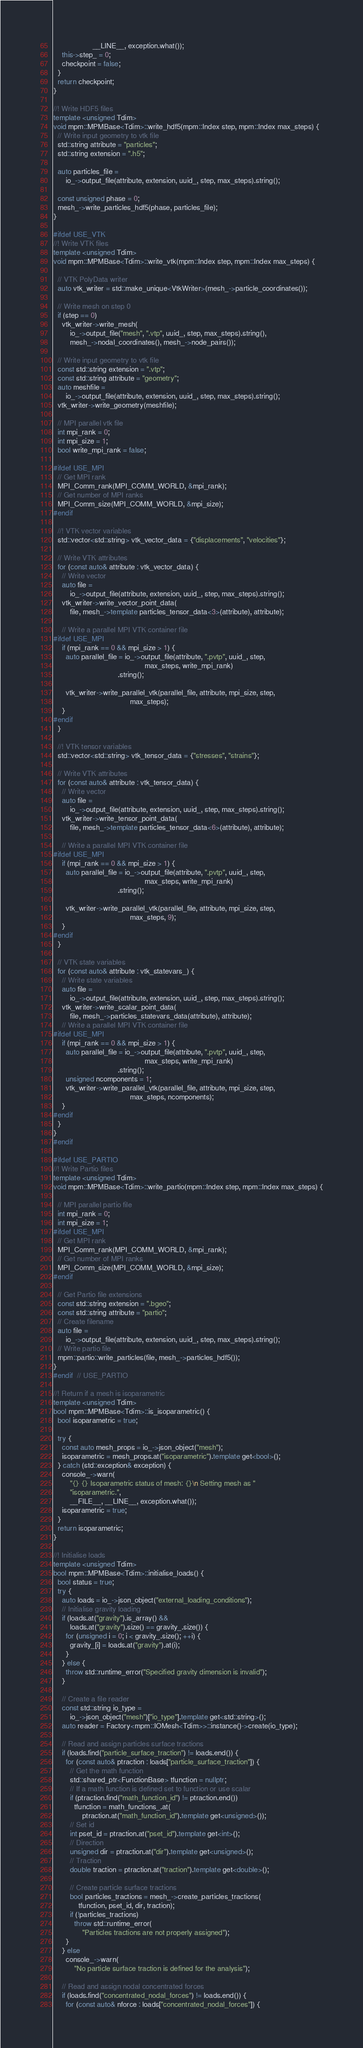Convert code to text. <code><loc_0><loc_0><loc_500><loc_500><_C++_>                   __LINE__, exception.what());
    this->step_ = 0;
    checkpoint = false;
  }
  return checkpoint;
}

//! Write HDF5 files
template <unsigned Tdim>
void mpm::MPMBase<Tdim>::write_hdf5(mpm::Index step, mpm::Index max_steps) {
  // Write input geometry to vtk file
  std::string attribute = "particles";
  std::string extension = ".h5";

  auto particles_file =
      io_->output_file(attribute, extension, uuid_, step, max_steps).string();

  const unsigned phase = 0;
  mesh_->write_particles_hdf5(phase, particles_file);
}

#ifdef USE_VTK
//! Write VTK files
template <unsigned Tdim>
void mpm::MPMBase<Tdim>::write_vtk(mpm::Index step, mpm::Index max_steps) {

  // VTK PolyData writer
  auto vtk_writer = std::make_unique<VtkWriter>(mesh_->particle_coordinates());

  // Write mesh on step 0
  if (step == 0)
    vtk_writer->write_mesh(
        io_->output_file("mesh", ".vtp", uuid_, step, max_steps).string(),
        mesh_->nodal_coordinates(), mesh_->node_pairs());

  // Write input geometry to vtk file
  const std::string extension = ".vtp";
  const std::string attribute = "geometry";
  auto meshfile =
      io_->output_file(attribute, extension, uuid_, step, max_steps).string();
  vtk_writer->write_geometry(meshfile);

  // MPI parallel vtk file
  int mpi_rank = 0;
  int mpi_size = 1;
  bool write_mpi_rank = false;

#ifdef USE_MPI
  // Get MPI rank
  MPI_Comm_rank(MPI_COMM_WORLD, &mpi_rank);
  // Get number of MPI ranks
  MPI_Comm_size(MPI_COMM_WORLD, &mpi_size);
#endif

  //! VTK vector variables
  std::vector<std::string> vtk_vector_data = {"displacements", "velocities"};

  // Write VTK attributes
  for (const auto& attribute : vtk_vector_data) {
    // Write vector
    auto file =
        io_->output_file(attribute, extension, uuid_, step, max_steps).string();
    vtk_writer->write_vector_point_data(
        file, mesh_->template particles_tensor_data<3>(attribute), attribute);

    // Write a parallel MPI VTK container file
#ifdef USE_MPI
    if (mpi_rank == 0 && mpi_size > 1) {
      auto parallel_file = io_->output_file(attribute, ".pvtp", uuid_, step,
                                            max_steps, write_mpi_rank)
                               .string();

      vtk_writer->write_parallel_vtk(parallel_file, attribute, mpi_size, step,
                                     max_steps);
    }
#endif
  }

  //! VTK tensor variables
  std::vector<std::string> vtk_tensor_data = {"stresses", "strains"};

  // Write VTK attributes
  for (const auto& attribute : vtk_tensor_data) {
    // Write vector
    auto file =
        io_->output_file(attribute, extension, uuid_, step, max_steps).string();
    vtk_writer->write_tensor_point_data(
        file, mesh_->template particles_tensor_data<6>(attribute), attribute);

    // Write a parallel MPI VTK container file
#ifdef USE_MPI
    if (mpi_rank == 0 && mpi_size > 1) {
      auto parallel_file = io_->output_file(attribute, ".pvtp", uuid_, step,
                                            max_steps, write_mpi_rank)
                               .string();

      vtk_writer->write_parallel_vtk(parallel_file, attribute, mpi_size, step,
                                     max_steps, 9);
    }
#endif
  }

  // VTK state variables
  for (const auto& attribute : vtk_statevars_) {
    // Write state variables
    auto file =
        io_->output_file(attribute, extension, uuid_, step, max_steps).string();
    vtk_writer->write_scalar_point_data(
        file, mesh_->particles_statevars_data(attribute), attribute);
    // Write a parallel MPI VTK container file
#ifdef USE_MPI
    if (mpi_rank == 0 && mpi_size > 1) {
      auto parallel_file = io_->output_file(attribute, ".pvtp", uuid_, step,
                                            max_steps, write_mpi_rank)
                               .string();
      unsigned ncomponents = 1;
      vtk_writer->write_parallel_vtk(parallel_file, attribute, mpi_size, step,
                                     max_steps, ncomponents);
    }
#endif
  }
}
#endif

#ifdef USE_PARTIO
//! Write Partio files
template <unsigned Tdim>
void mpm::MPMBase<Tdim>::write_partio(mpm::Index step, mpm::Index max_steps) {

  // MPI parallel partio file
  int mpi_rank = 0;
  int mpi_size = 1;
#ifdef USE_MPI
  // Get MPI rank
  MPI_Comm_rank(MPI_COMM_WORLD, &mpi_rank);
  // Get number of MPI ranks
  MPI_Comm_size(MPI_COMM_WORLD, &mpi_size);
#endif

  // Get Partio file extensions
  const std::string extension = ".bgeo";
  const std::string attribute = "partio";
  // Create filename
  auto file =
      io_->output_file(attribute, extension, uuid_, step, max_steps).string();
  // Write partio file
  mpm::partio::write_particles(file, mesh_->particles_hdf5());
}
#endif  // USE_PARTIO

//! Return if a mesh is isoparametric
template <unsigned Tdim>
bool mpm::MPMBase<Tdim>::is_isoparametric() {
  bool isoparametric = true;

  try {
    const auto mesh_props = io_->json_object("mesh");
    isoparametric = mesh_props.at("isoparametric").template get<bool>();
  } catch (std::exception& exception) {
    console_->warn(
        "{} {} Isoparametric status of mesh: {}\n Setting mesh as "
        "isoparametric.",
        __FILE__, __LINE__, exception.what());
    isoparametric = true;
  }
  return isoparametric;
}

//! Initialise loads
template <unsigned Tdim>
bool mpm::MPMBase<Tdim>::initialise_loads() {
  bool status = true;
  try {
    auto loads = io_->json_object("external_loading_conditions");
    // Initialise gravity loading
    if (loads.at("gravity").is_array() &&
        loads.at("gravity").size() == gravity_.size()) {
      for (unsigned i = 0; i < gravity_.size(); ++i) {
        gravity_[i] = loads.at("gravity").at(i);
      }
    } else {
      throw std::runtime_error("Specified gravity dimension is invalid");
    }

    // Create a file reader
    const std::string io_type =
        io_->json_object("mesh")["io_type"].template get<std::string>();
    auto reader = Factory<mpm::IOMesh<Tdim>>::instance()->create(io_type);

    // Read and assign particles surface tractions
    if (loads.find("particle_surface_traction") != loads.end()) {
      for (const auto& ptraction : loads["particle_surface_traction"]) {
        // Get the math function
        std::shared_ptr<FunctionBase> tfunction = nullptr;
        // If a math function is defined set to function or use scalar
        if (ptraction.find("math_function_id") != ptraction.end())
          tfunction = math_functions_.at(
              ptraction.at("math_function_id").template get<unsigned>());
        // Set id
        int pset_id = ptraction.at("pset_id").template get<int>();
        // Direction
        unsigned dir = ptraction.at("dir").template get<unsigned>();
        // Traction
        double traction = ptraction.at("traction").template get<double>();

        // Create particle surface tractions
        bool particles_tractions = mesh_->create_particles_tractions(
            tfunction, pset_id, dir, traction);
        if (!particles_tractions)
          throw std::runtime_error(
              "Particles tractions are not properly assigned");
      }
    } else
      console_->warn(
          "No particle surface traction is defined for the analysis");

    // Read and assign nodal concentrated forces
    if (loads.find("concentrated_nodal_forces") != loads.end()) {
      for (const auto& nforce : loads["concentrated_nodal_forces"]) {</code> 